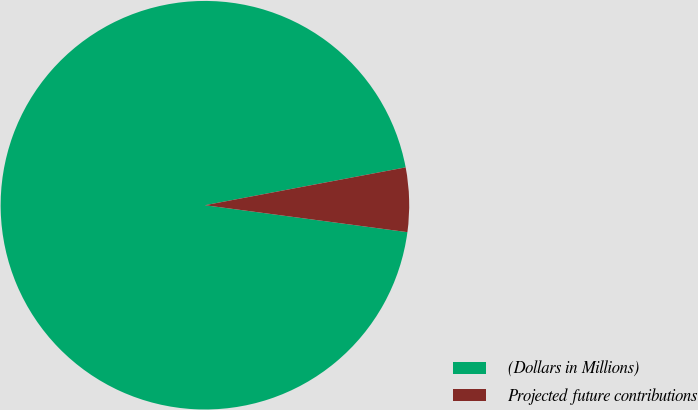<chart> <loc_0><loc_0><loc_500><loc_500><pie_chart><fcel>(Dollars in Millions)<fcel>Projected future contributions<nl><fcel>94.93%<fcel>5.07%<nl></chart> 